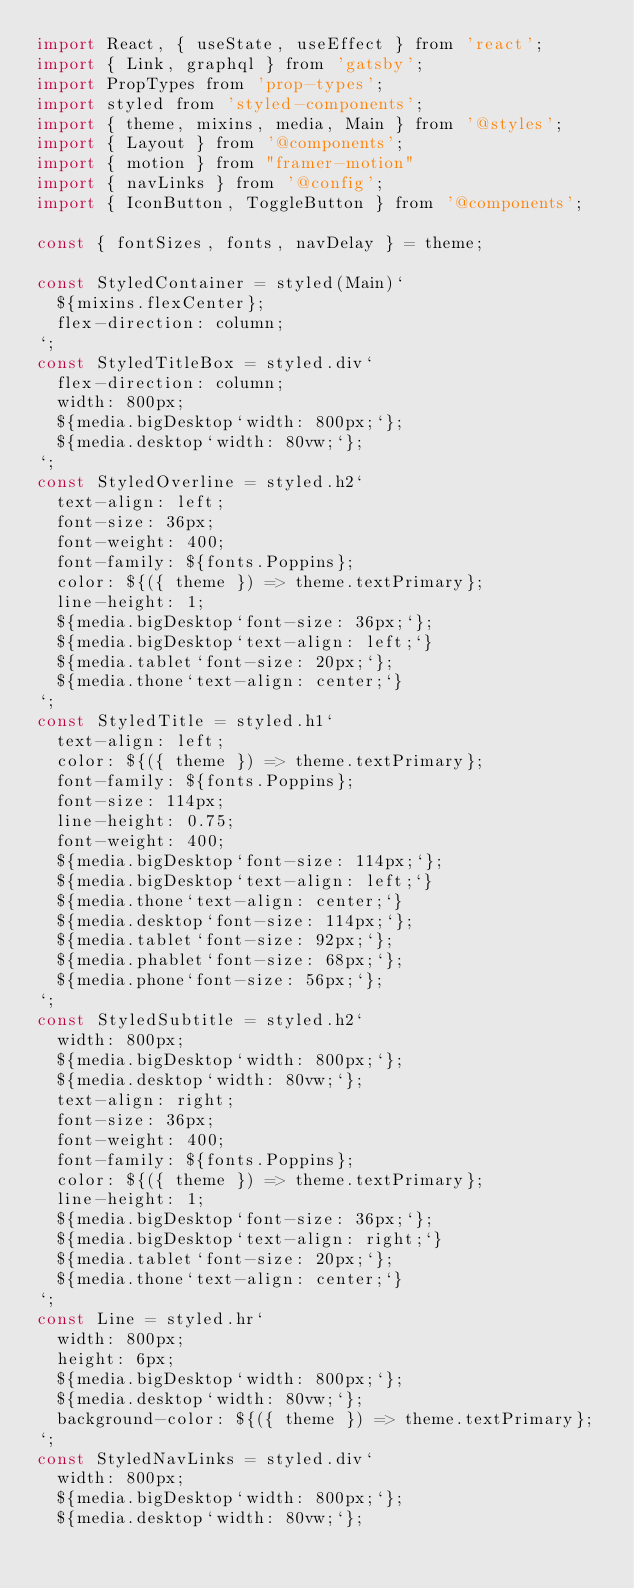<code> <loc_0><loc_0><loc_500><loc_500><_JavaScript_>import React, { useState, useEffect } from 'react';
import { Link, graphql } from 'gatsby';
import PropTypes from 'prop-types';
import styled from 'styled-components';
import { theme, mixins, media, Main } from '@styles';
import { Layout } from '@components';
import { motion } from "framer-motion"
import { navLinks } from '@config';
import { IconButton, ToggleButton } from '@components';

const { fontSizes, fonts, navDelay } = theme;

const StyledContainer = styled(Main)`
  ${mixins.flexCenter};
  flex-direction: column;
`;
const StyledTitleBox = styled.div`
  flex-direction: column;
  width: 800px;
  ${media.bigDesktop`width: 800px;`};
  ${media.desktop`width: 80vw;`};
`;
const StyledOverline = styled.h2`
  text-align: left;
  font-size: 36px;
  font-weight: 400;
  font-family: ${fonts.Poppins};
  color: ${({ theme }) => theme.textPrimary};
  line-height: 1;
  ${media.bigDesktop`font-size: 36px;`};
  ${media.bigDesktop`text-align: left;`}
  ${media.tablet`font-size: 20px;`};
  ${media.thone`text-align: center;`}
`;
const StyledTitle = styled.h1`
  text-align: left;
  color: ${({ theme }) => theme.textPrimary};
  font-family: ${fonts.Poppins};
  font-size: 114px;
  line-height: 0.75;
  font-weight: 400;
  ${media.bigDesktop`font-size: 114px;`};
  ${media.bigDesktop`text-align: left;`}
  ${media.thone`text-align: center;`}
  ${media.desktop`font-size: 114px;`};
  ${media.tablet`font-size: 92px;`};
  ${media.phablet`font-size: 68px;`};
  ${media.phone`font-size: 56px;`};
`;
const StyledSubtitle = styled.h2`
  width: 800px;
  ${media.bigDesktop`width: 800px;`};
  ${media.desktop`width: 80vw;`};
  text-align: right;
  font-size: 36px;
  font-weight: 400;
  font-family: ${fonts.Poppins};
  color: ${({ theme }) => theme.textPrimary};
  line-height: 1;
  ${media.bigDesktop`font-size: 36px;`};
  ${media.bigDesktop`text-align: right;`}
  ${media.tablet`font-size: 20px;`};
  ${media.thone`text-align: center;`}
`;
const Line = styled.hr`
  width: 800px;
  height: 6px;
  ${media.bigDesktop`width: 800px;`};
  ${media.desktop`width: 80vw;`};
  background-color: ${({ theme }) => theme.textPrimary};
`;
const StyledNavLinks = styled.div`
  width: 800px;
  ${media.bigDesktop`width: 800px;`};
  ${media.desktop`width: 80vw;`};</code> 